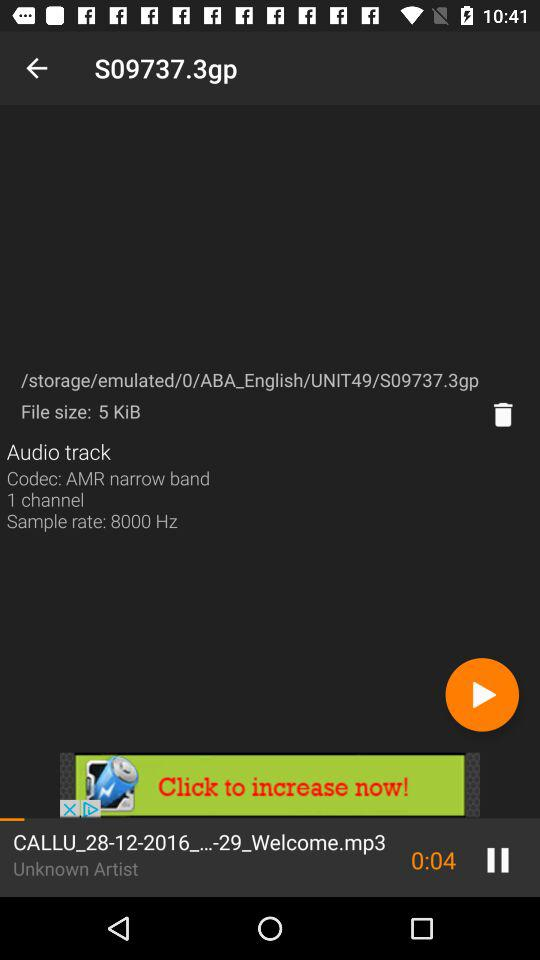What is the file size of the audio track?
Answer the question using a single word or phrase. 5 KiB 